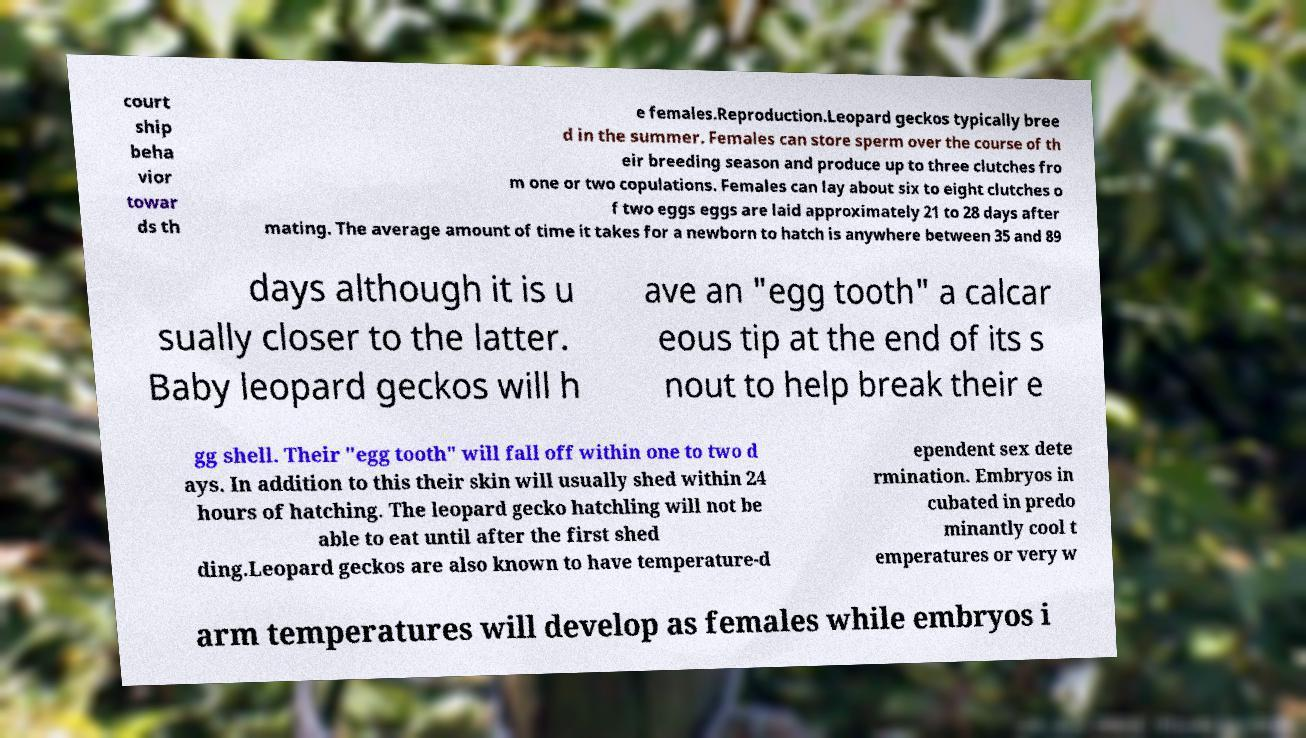What messages or text are displayed in this image? I need them in a readable, typed format. court ship beha vior towar ds th e females.Reproduction.Leopard geckos typically bree d in the summer. Females can store sperm over the course of th eir breeding season and produce up to three clutches fro m one or two copulations. Females can lay about six to eight clutches o f two eggs eggs are laid approximately 21 to 28 days after mating. The average amount of time it takes for a newborn to hatch is anywhere between 35 and 89 days although it is u sually closer to the latter. Baby leopard geckos will h ave an "egg tooth" a calcar eous tip at the end of its s nout to help break their e gg shell. Their "egg tooth" will fall off within one to two d ays. In addition to this their skin will usually shed within 24 hours of hatching. The leopard gecko hatchling will not be able to eat until after the first shed ding.Leopard geckos are also known to have temperature-d ependent sex dete rmination. Embryos in cubated in predo minantly cool t emperatures or very w arm temperatures will develop as females while embryos i 